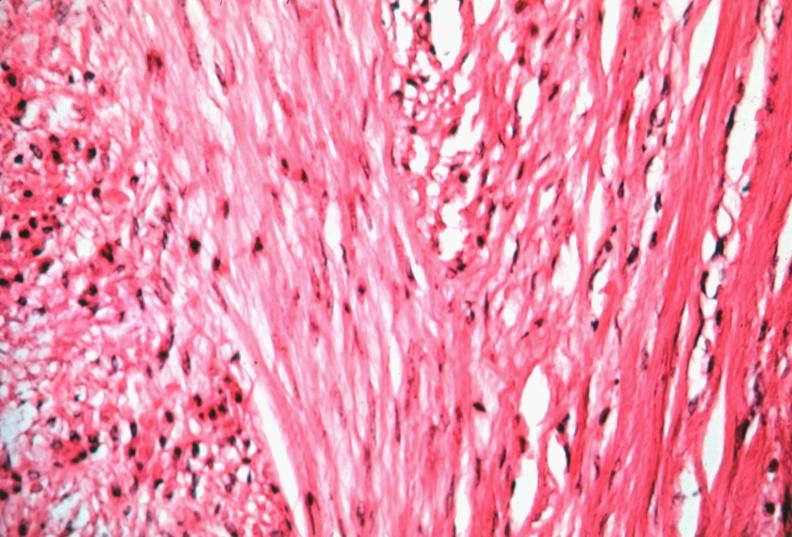where is this from?
Answer the question using a single word or phrase. Female reproductive system 